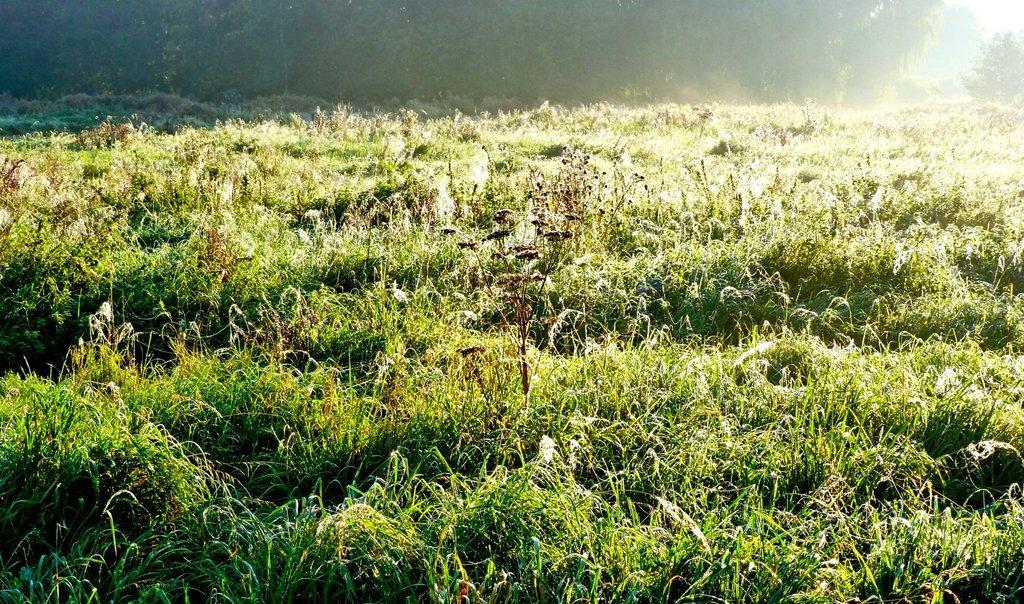How would you summarize this image in a sentence or two? In this picture we can see the farmland. In the background we can see many trees. At the bottom we can see plants. In the top right corner there is a sky. 